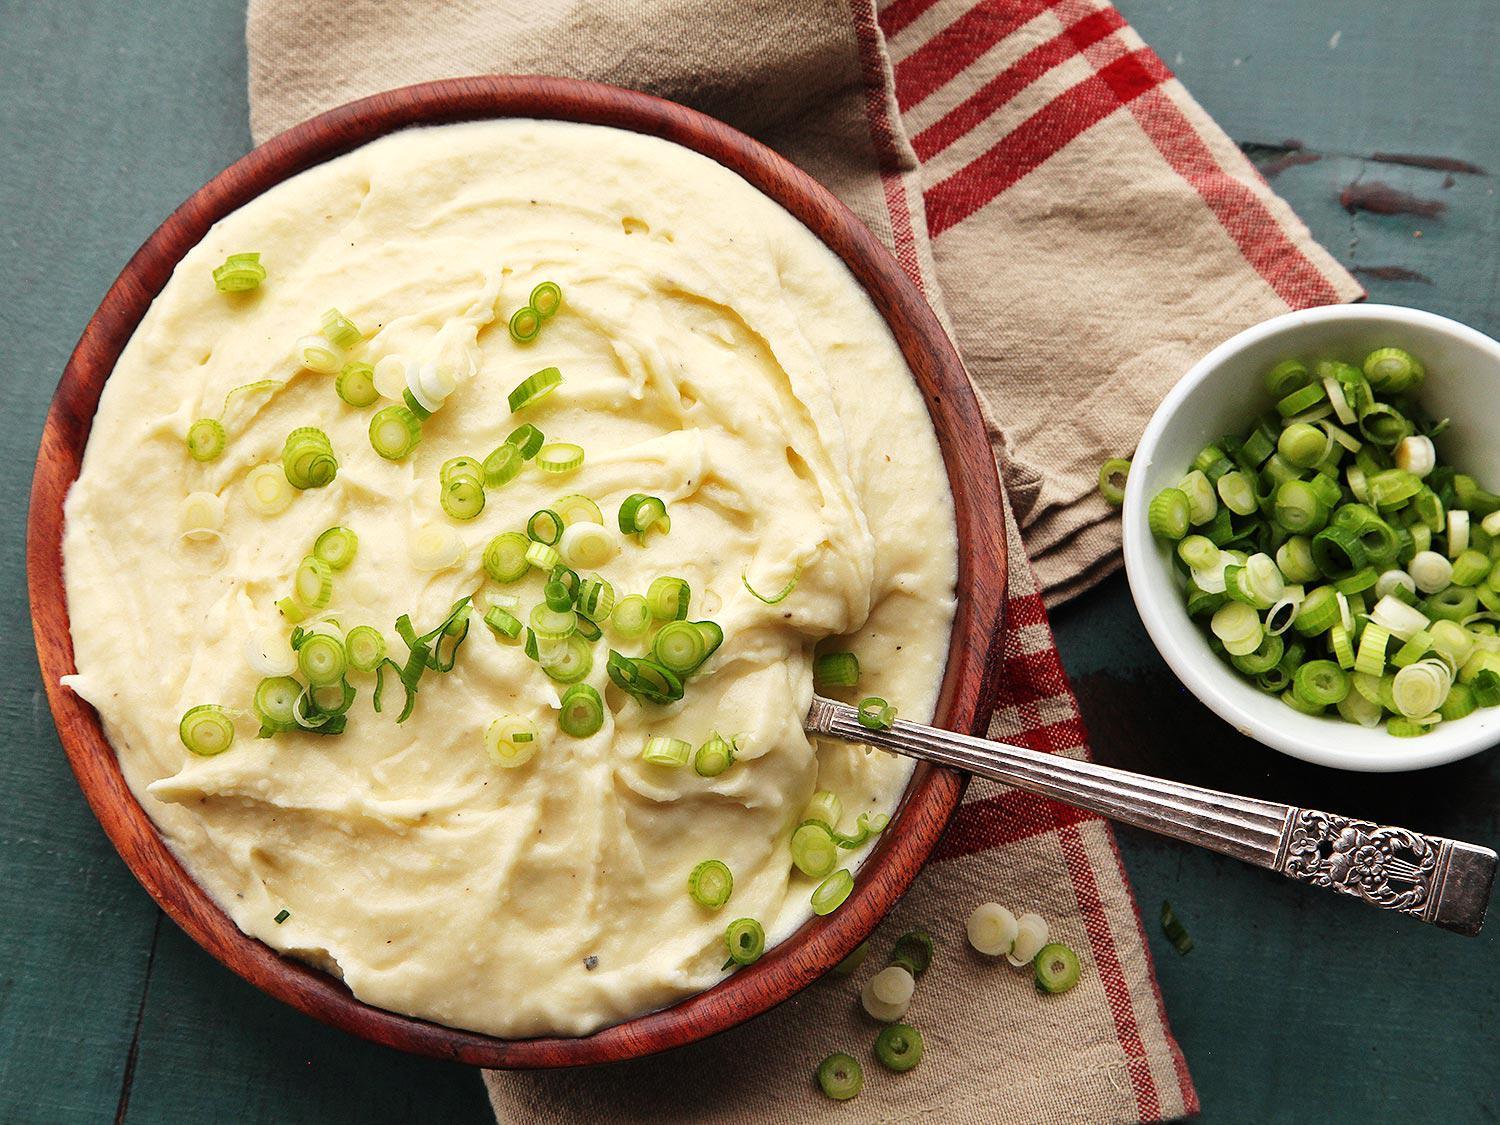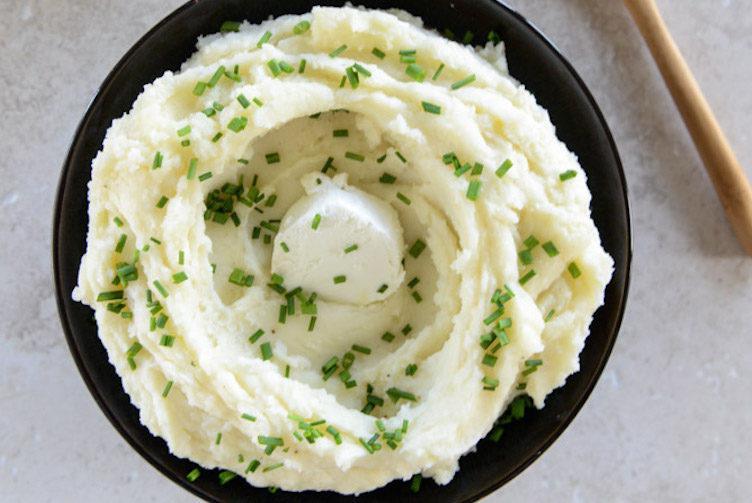The first image is the image on the left, the second image is the image on the right. Considering the images on both sides, is "One image shows potatoes garnished with green bits and served in a shiny olive green bowl." valid? Answer yes or no. No. The first image is the image on the left, the second image is the image on the right. Assess this claim about the two images: "In one of the images, the mashed potatoes are in a green bowl.". Correct or not? Answer yes or no. No. 